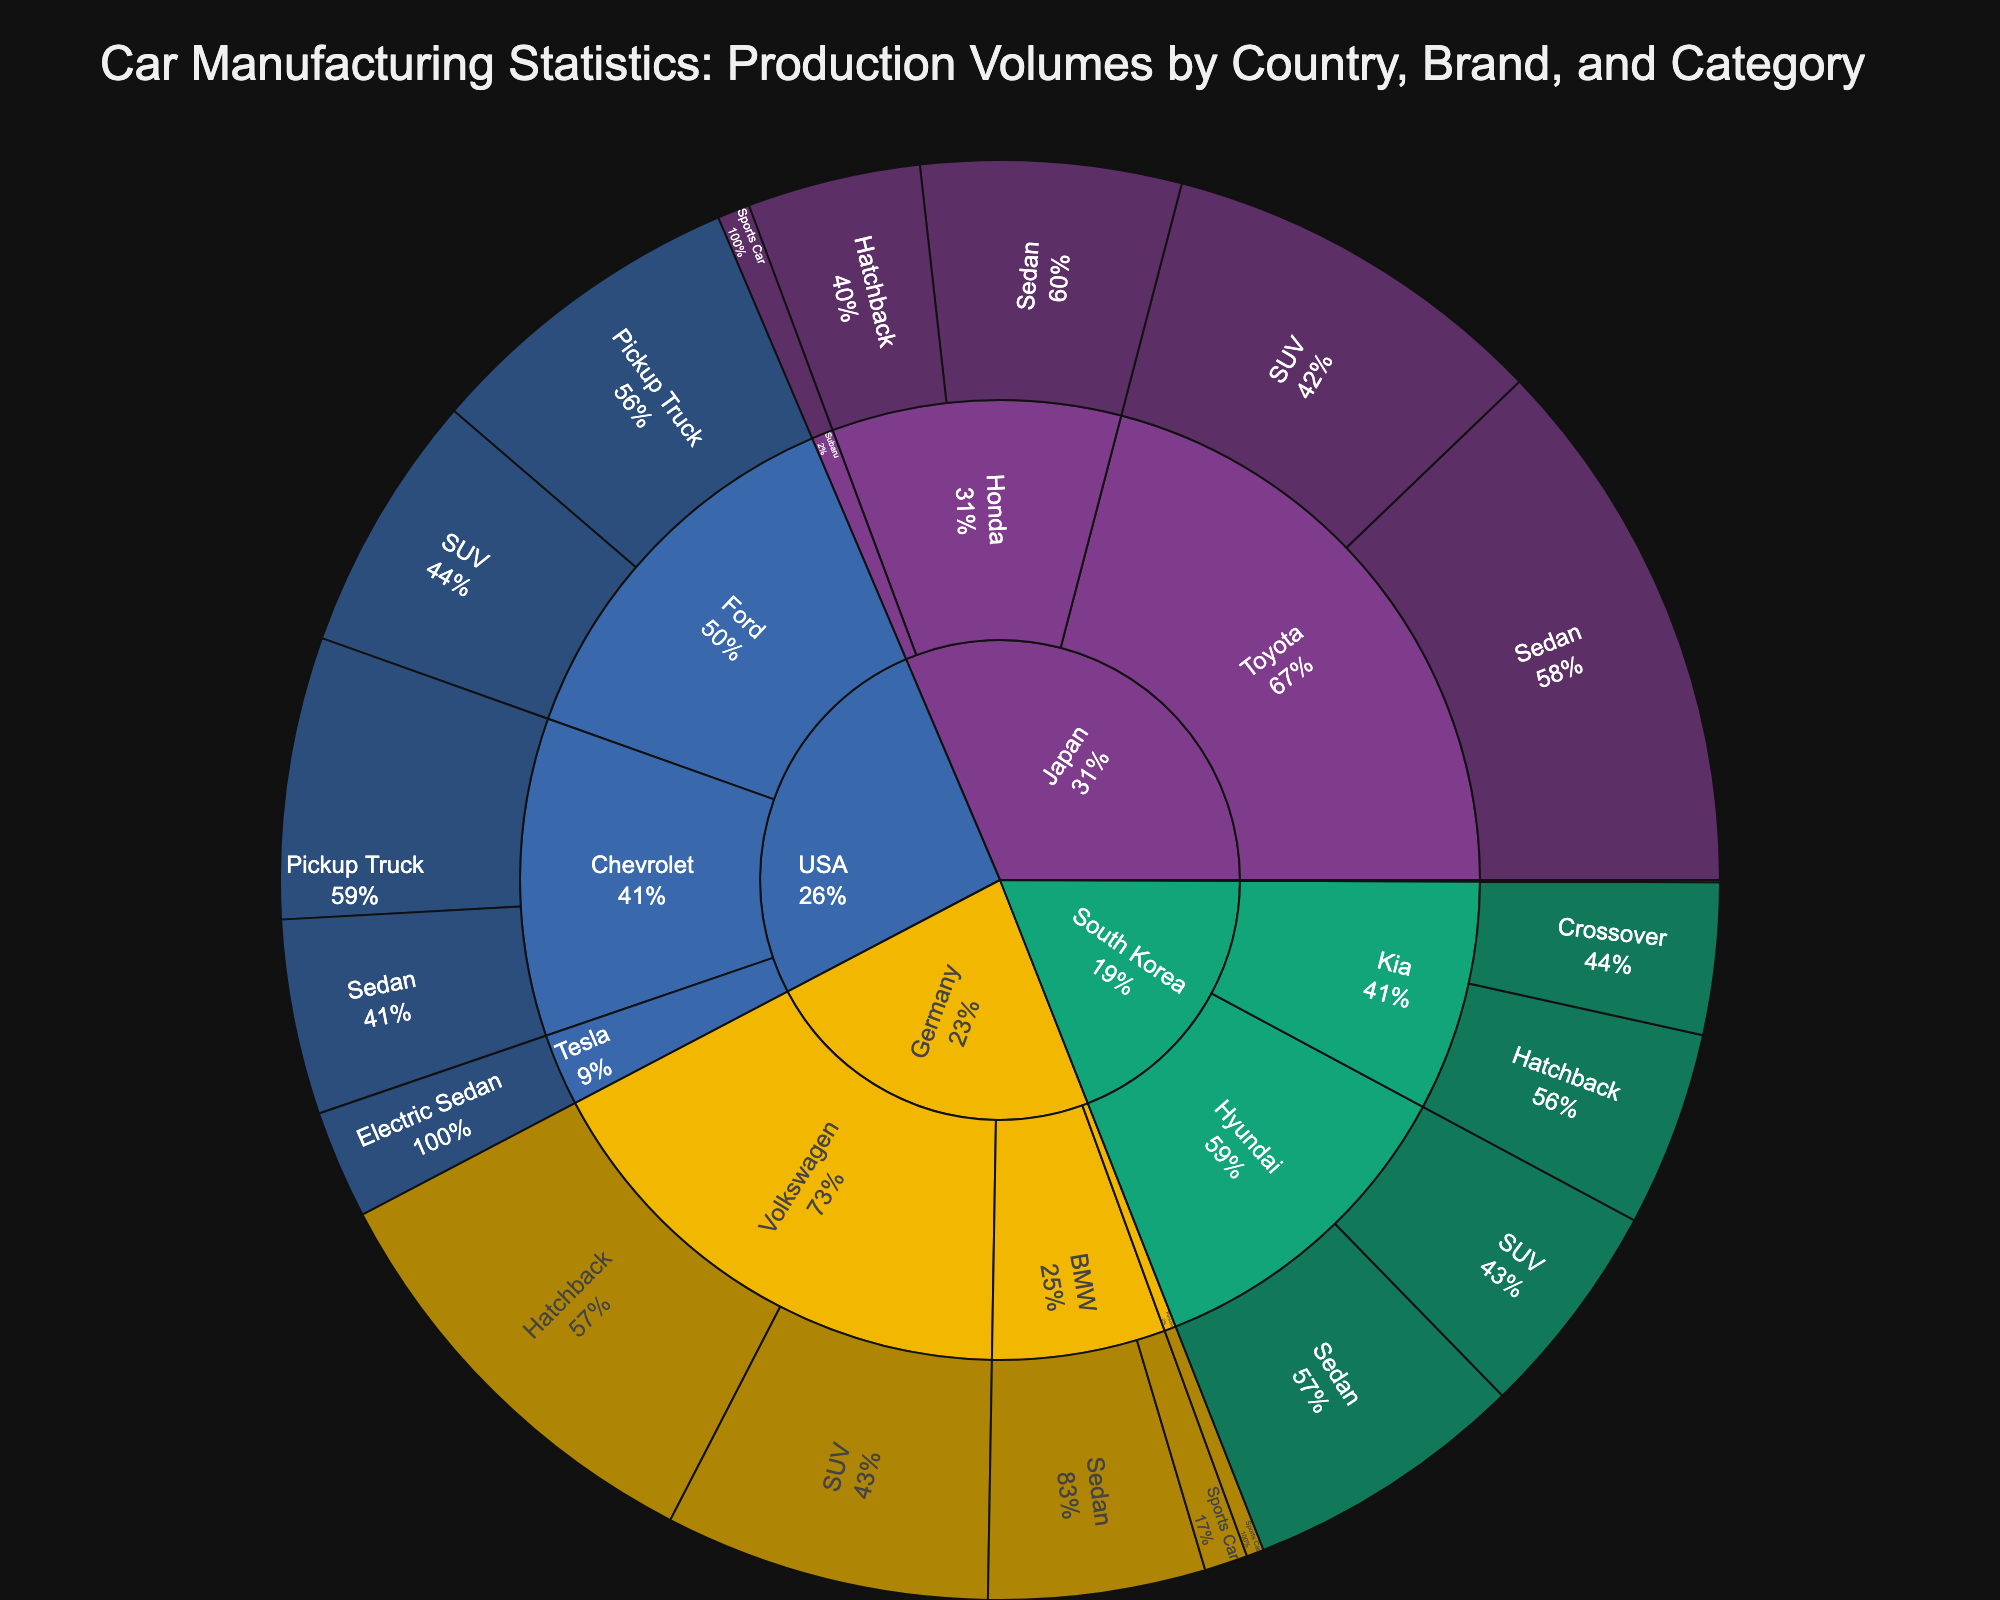What is the title of the plot? The title is displayed prominently at the top of the plot. It describes the overall theme and scope of the visualization.
Answer: Car Manufacturing Statistics: Production Volumes by Country, Brand, and Category Which country has the highest production volume for sedans? Identify the sections labeled as sedans within each country's segment and compare their production volumes.
Answer: Japan What is the total production volume for vehicles in Germany? Sum the production volumes of all vehicle categories for brands originating from Germany. This includes all segments under 'Germany' in the plot.
Answer: 4,780,000 How does the production volume of SUVs in the US compare to those in Japan? Locate the segments for SUVs under both the US and Japan, then compare their production volumes directly.
Answer: The US has more SUVs (1,200,000 by Ford) compared to Japan (1,800,000 by Toyota) Which brand has the smallest production volume and which category does it belong to? Identify the brand segment with the smallest numerical value and note the corresponding vehicle category.
Answer: Ferrari, Sports Car Calculate the average production volume for sedans across all countries. Sum the production volumes for all sedan segments and divide by the number of sedan segments. The sedan production volumes are: 2500000 (Toyota), 1200000 (Honda), 1000000 (BMW), 900000 (Chevrolet), 500000 (Tesla), 1300000 (Hyundai). (2500000 + 1200000 + 1000000 + 900000 + 500000 + 1300000) / 6 = 7400000 / 6
Answer: 1,233,333 Compare the production volume of sports cars in Germany to that in Italy. Identify the sports car segments under Germany (BMW and Porsche) and Italy (Ferrari), then sum and compare their volumes.
Answer: Germany has more (280,000 vs 10,000) Which country has the most diverse range of vehicle categories? Count the different vehicle categories under each country segment, and the one with the greatest number is the most diverse.
Answer: Japan (Sedan, SUV, Hatchback, Sports Car) 